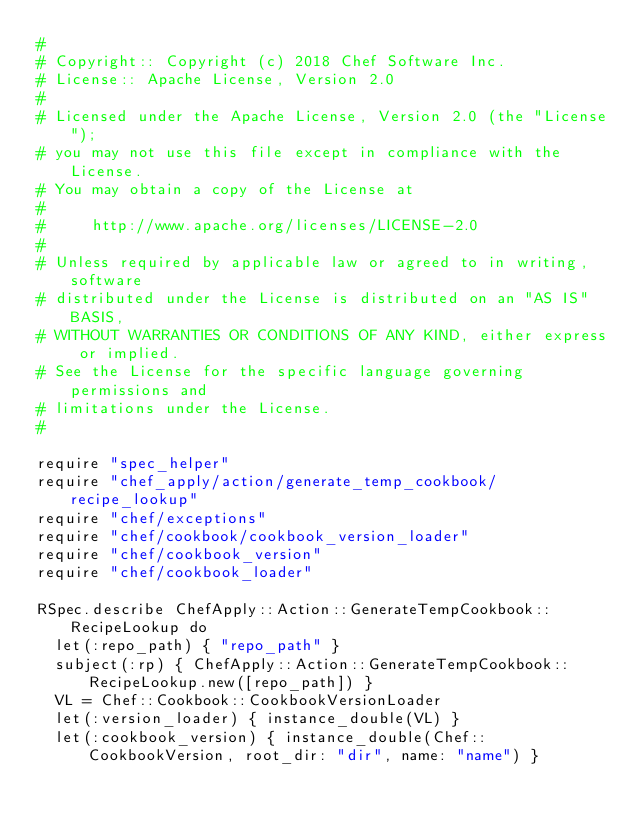<code> <loc_0><loc_0><loc_500><loc_500><_Ruby_>#
# Copyright:: Copyright (c) 2018 Chef Software Inc.
# License:: Apache License, Version 2.0
#
# Licensed under the Apache License, Version 2.0 (the "License");
# you may not use this file except in compliance with the License.
# You may obtain a copy of the License at
#
#     http://www.apache.org/licenses/LICENSE-2.0
#
# Unless required by applicable law or agreed to in writing, software
# distributed under the License is distributed on an "AS IS" BASIS,
# WITHOUT WARRANTIES OR CONDITIONS OF ANY KIND, either express or implied.
# See the License for the specific language governing permissions and
# limitations under the License.
#

require "spec_helper"
require "chef_apply/action/generate_temp_cookbook/recipe_lookup"
require "chef/exceptions"
require "chef/cookbook/cookbook_version_loader"
require "chef/cookbook_version"
require "chef/cookbook_loader"

RSpec.describe ChefApply::Action::GenerateTempCookbook::RecipeLookup do
  let(:repo_path) { "repo_path" }
  subject(:rp) { ChefApply::Action::GenerateTempCookbook::RecipeLookup.new([repo_path]) }
  VL = Chef::Cookbook::CookbookVersionLoader
  let(:version_loader) { instance_double(VL) }
  let(:cookbook_version) { instance_double(Chef::CookbookVersion, root_dir: "dir", name: "name") }</code> 